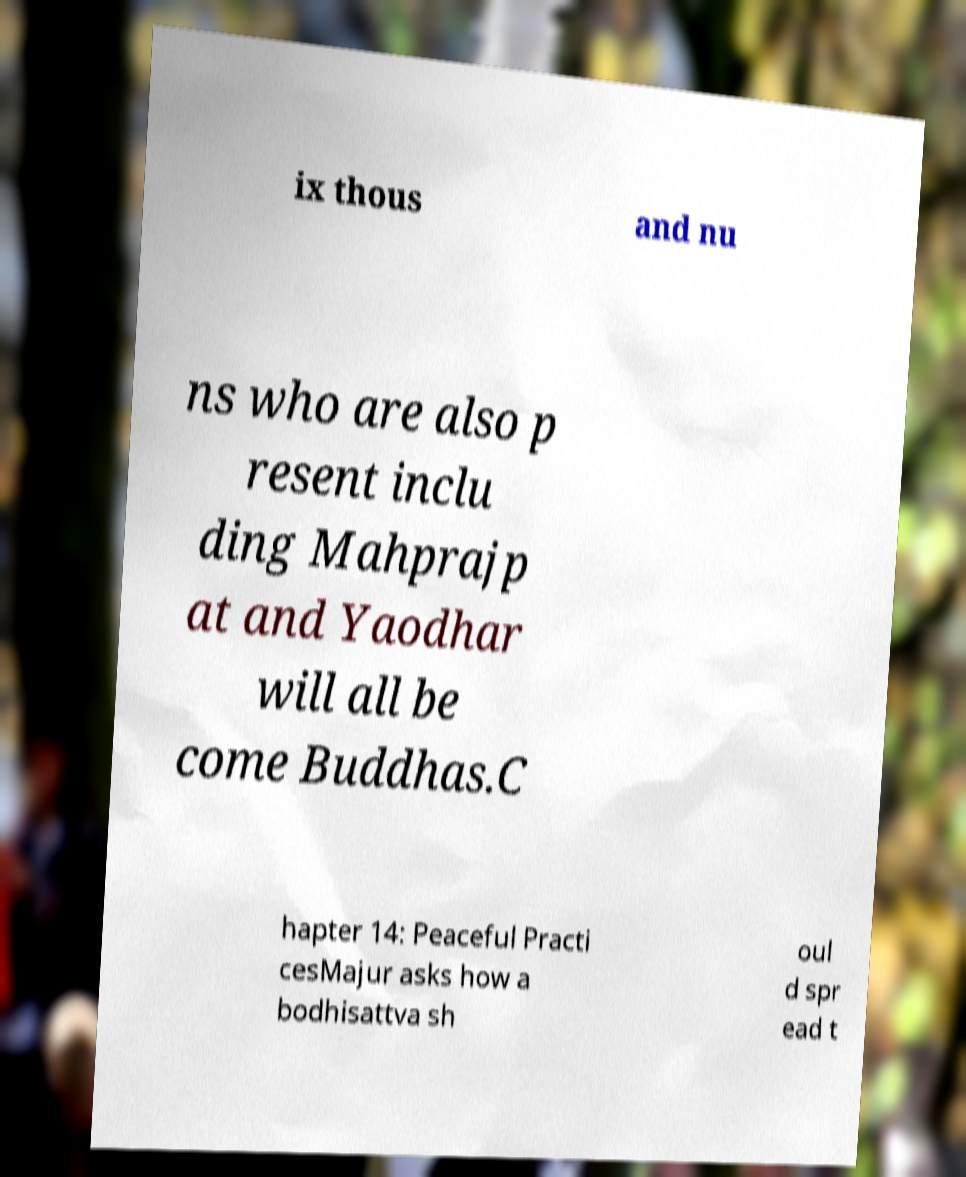Please identify and transcribe the text found in this image. ix thous and nu ns who are also p resent inclu ding Mahprajp at and Yaodhar will all be come Buddhas.C hapter 14: Peaceful Practi cesMajur asks how a bodhisattva sh oul d spr ead t 